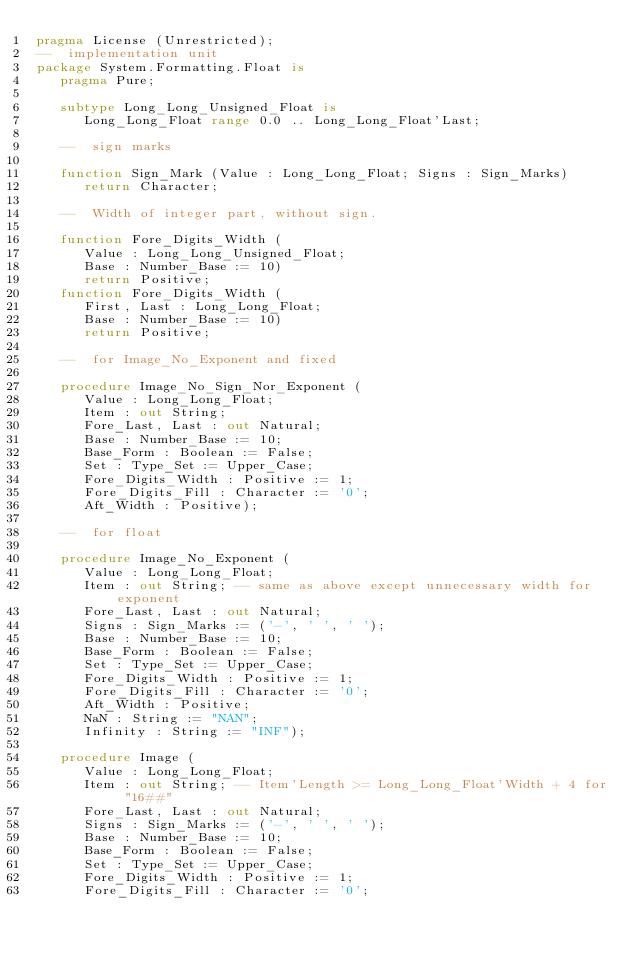<code> <loc_0><loc_0><loc_500><loc_500><_Ada_>pragma License (Unrestricted);
--  implementation unit
package System.Formatting.Float is
   pragma Pure;

   subtype Long_Long_Unsigned_Float is
      Long_Long_Float range 0.0 .. Long_Long_Float'Last;

   --  sign marks

   function Sign_Mark (Value : Long_Long_Float; Signs : Sign_Marks)
      return Character;

   --  Width of integer part, without sign.

   function Fore_Digits_Width (
      Value : Long_Long_Unsigned_Float;
      Base : Number_Base := 10)
      return Positive;
   function Fore_Digits_Width (
      First, Last : Long_Long_Float;
      Base : Number_Base := 10)
      return Positive;

   --  for Image_No_Exponent and fixed

   procedure Image_No_Sign_Nor_Exponent (
      Value : Long_Long_Float;
      Item : out String;
      Fore_Last, Last : out Natural;
      Base : Number_Base := 10;
      Base_Form : Boolean := False;
      Set : Type_Set := Upper_Case;
      Fore_Digits_Width : Positive := 1;
      Fore_Digits_Fill : Character := '0';
      Aft_Width : Positive);

   --  for float

   procedure Image_No_Exponent (
      Value : Long_Long_Float;
      Item : out String; -- same as above except unnecessary width for exponent
      Fore_Last, Last : out Natural;
      Signs : Sign_Marks := ('-', ' ', ' ');
      Base : Number_Base := 10;
      Base_Form : Boolean := False;
      Set : Type_Set := Upper_Case;
      Fore_Digits_Width : Positive := 1;
      Fore_Digits_Fill : Character := '0';
      Aft_Width : Positive;
      NaN : String := "NAN";
      Infinity : String := "INF");

   procedure Image (
      Value : Long_Long_Float;
      Item : out String; -- Item'Length >= Long_Long_Float'Width + 4 for "16##"
      Fore_Last, Last : out Natural;
      Signs : Sign_Marks := ('-', ' ', ' ');
      Base : Number_Base := 10;
      Base_Form : Boolean := False;
      Set : Type_Set := Upper_Case;
      Fore_Digits_Width : Positive := 1;
      Fore_Digits_Fill : Character := '0';</code> 